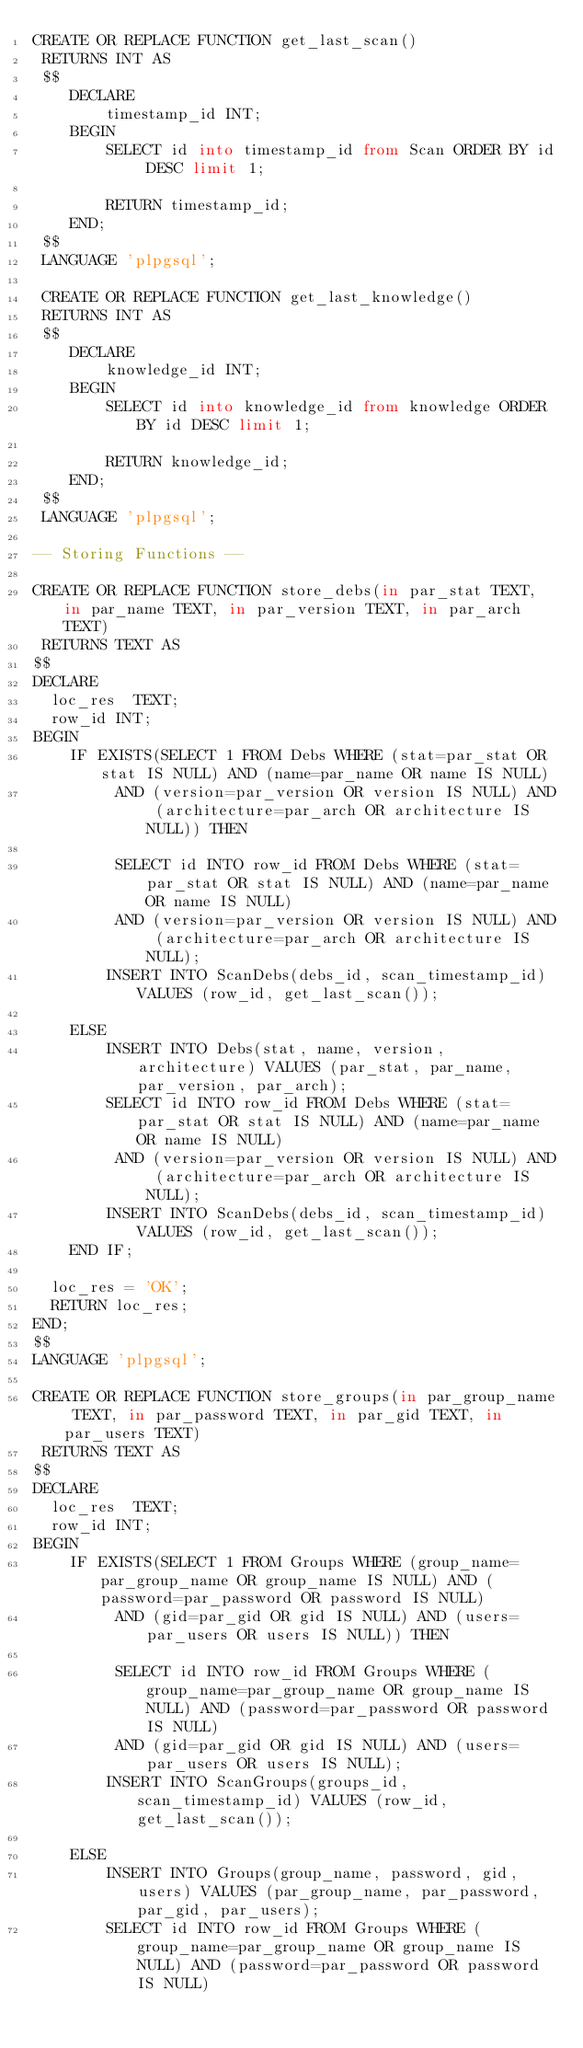Convert code to text. <code><loc_0><loc_0><loc_500><loc_500><_SQL_>CREATE OR REPLACE FUNCTION get_last_scan()
 RETURNS INT AS
 $$
    DECLARE
        timestamp_id INT;
    BEGIN
        SELECT id into timestamp_id from Scan ORDER BY id DESC limit 1;

        RETURN timestamp_id;
    END;
 $$
 LANGUAGE 'plpgsql';

 CREATE OR REPLACE FUNCTION get_last_knowledge()
 RETURNS INT AS
 $$
    DECLARE
        knowledge_id INT;
    BEGIN
        SELECT id into knowledge_id from knowledge ORDER BY id DESC limit 1;

        RETURN knowledge_id;
    END;
 $$
 LANGUAGE 'plpgsql';

-- Storing Functions --

CREATE OR REPLACE FUNCTION store_debs(in par_stat TEXT, in par_name TEXT, in par_version TEXT, in par_arch TEXT)
 RETURNS TEXT AS
$$
DECLARE
  loc_res  TEXT;
  row_id INT;
BEGIN
    IF EXISTS(SELECT 1 FROM Debs WHERE (stat=par_stat OR stat IS NULL) AND (name=par_name OR name IS NULL)
         AND (version=par_version OR version IS NULL) AND (architecture=par_arch OR architecture IS NULL)) THEN

         SELECT id INTO row_id FROM Debs WHERE (stat=par_stat OR stat IS NULL) AND (name=par_name OR name IS NULL)
         AND (version=par_version OR version IS NULL) AND (architecture=par_arch OR architecture IS NULL);
        INSERT INTO ScanDebs(debs_id, scan_timestamp_id) VALUES (row_id, get_last_scan());

    ELSE
        INSERT INTO Debs(stat, name, version, architecture) VALUES (par_stat, par_name, par_version, par_arch);
        SELECT id INTO row_id FROM Debs WHERE (stat=par_stat OR stat IS NULL) AND (name=par_name OR name IS NULL)
         AND (version=par_version OR version IS NULL) AND (architecture=par_arch OR architecture IS NULL);
        INSERT INTO ScanDebs(debs_id, scan_timestamp_id) VALUES (row_id, get_last_scan());
    END IF;

  loc_res = 'OK';
  RETURN loc_res;
END;
$$
LANGUAGE 'plpgsql';

CREATE OR REPLACE FUNCTION store_groups(in par_group_name TEXT, in par_password TEXT, in par_gid TEXT, in par_users TEXT)
 RETURNS TEXT AS
$$
DECLARE
  loc_res  TEXT;
  row_id INT;
BEGIN
    IF EXISTS(SELECT 1 FROM Groups WHERE (group_name=par_group_name OR group_name IS NULL) AND (password=par_password OR password IS NULL)
         AND (gid=par_gid OR gid IS NULL) AND (users=par_users OR users IS NULL)) THEN

         SELECT id INTO row_id FROM Groups WHERE (group_name=par_group_name OR group_name IS NULL) AND (password=par_password OR password IS NULL)
         AND (gid=par_gid OR gid IS NULL) AND (users=par_users OR users IS NULL);
        INSERT INTO ScanGroups(groups_id, scan_timestamp_id) VALUES (row_id, get_last_scan());

    ELSE
        INSERT INTO Groups(group_name, password, gid, users) VALUES (par_group_name, par_password, par_gid, par_users);
        SELECT id INTO row_id FROM Groups WHERE (group_name=par_group_name OR group_name IS NULL) AND (password=par_password OR password IS NULL)</code> 